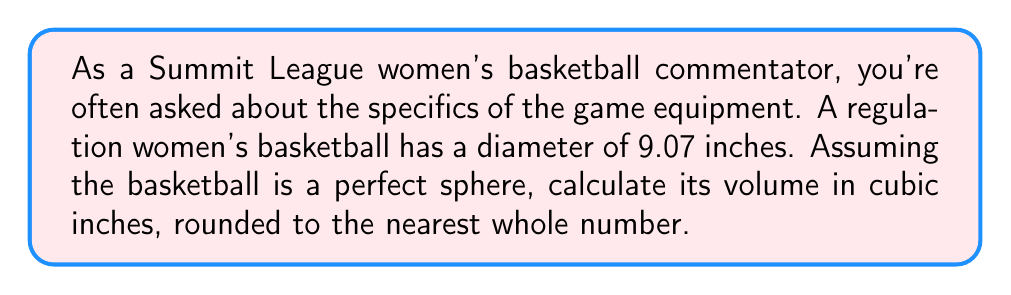Give your solution to this math problem. To find the volume of a basketball, we need to use the formula for the volume of a sphere:

$$V = \frac{4}{3}\pi r^3$$

Where:
$V$ is the volume
$r$ is the radius of the sphere

Given:
- The diameter of the basketball is 9.07 inches
- The radius is half the diameter: $r = \frac{9.07}{2} = 4.535$ inches

Let's substitute this into our formula:

$$V = \frac{4}{3}\pi (4.535)^3$$

Now, let's calculate step-by-step:

1) First, calculate $r^3$:
   $4.535^3 = 93.176796875$

2) Multiply by $\frac{4}{3}$:
   $\frac{4}{3} \times 93.176796875 = 124.23572916667$

3) Multiply by $\pi$:
   $124.23572916667 \times \pi = 390.3175...$ cubic inches

4) Rounding to the nearest whole number:
   $390$ cubic inches

This calculation gives us the volume of a regulation women's basketball used in Summit League games.
Answer: The volume of a regulation women's basketball is approximately $390$ cubic inches. 